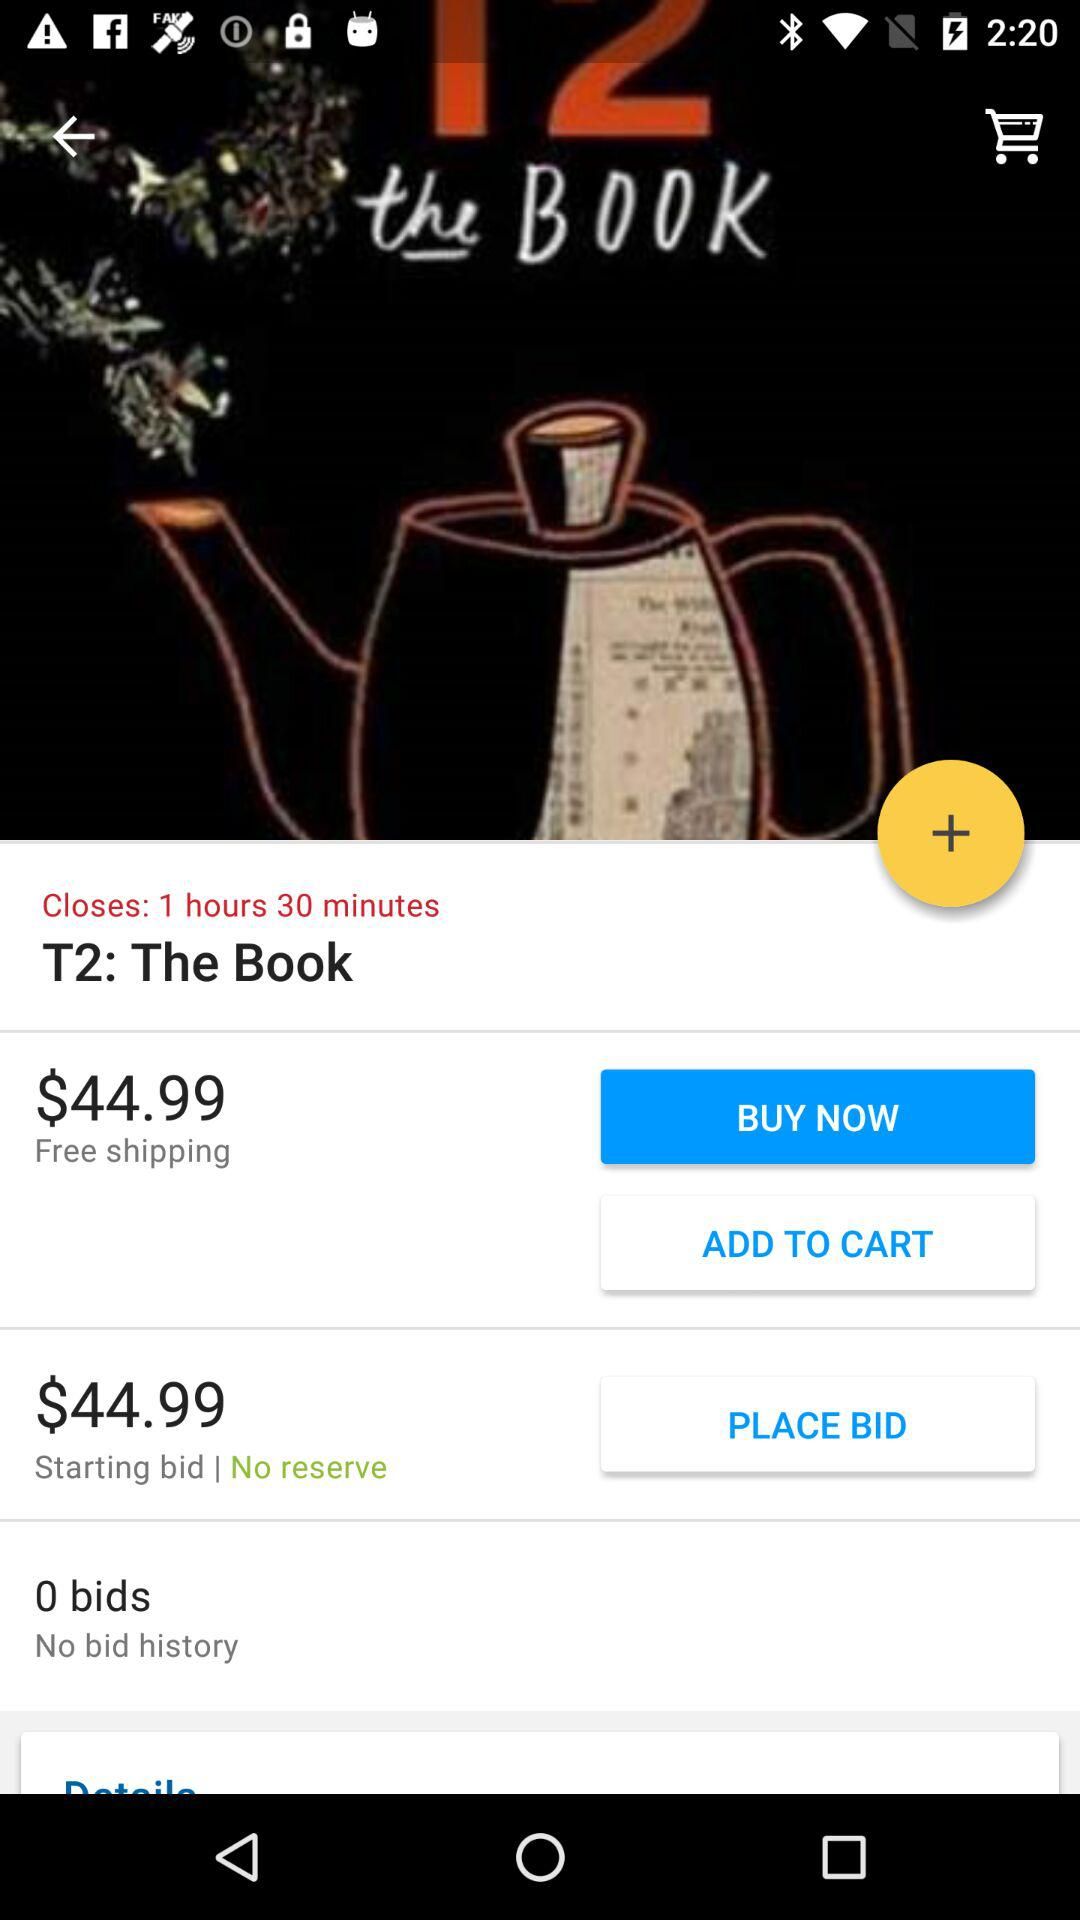How many bids are there?
Answer the question using a single word or phrase. 0 